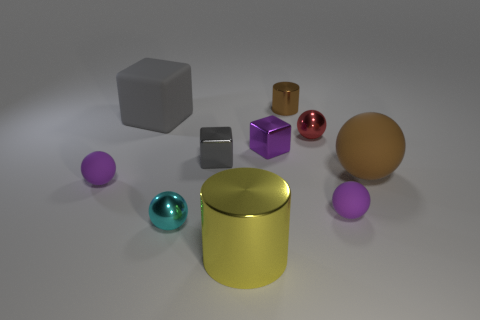Are all the objects here solid or are there any hollow shapes? It's not possible to determine the solidity from this image alone, but typically objects resembling these shapes can be either solid or hollow. We would need additional information to make a definitive assessment. If you had to guess based on their appearances, which ones might be hollow? Based on common uses and appearances, the gold cylinder and the larger spheres might be hollow, often used as containers or decorative pieces, whereas the cubes and smaller objects might be solid, providing more stability. 